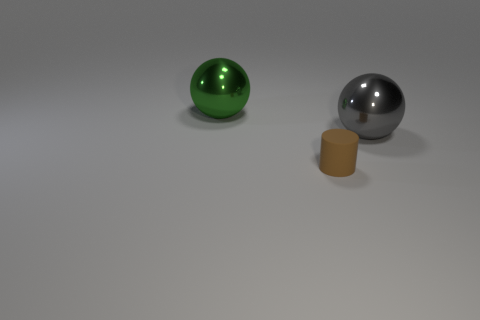Add 1 brown rubber cylinders. How many objects exist? 4 Subtract all cylinders. How many objects are left? 2 Subtract 1 balls. How many balls are left? 1 Subtract all brown balls. How many cyan cylinders are left? 0 Subtract 0 purple cubes. How many objects are left? 3 Subtract all gray balls. Subtract all purple cubes. How many balls are left? 1 Subtract all big metal spheres. Subtract all rubber things. How many objects are left? 0 Add 2 big shiny things. How many big shiny things are left? 4 Add 3 large metallic balls. How many large metallic balls exist? 5 